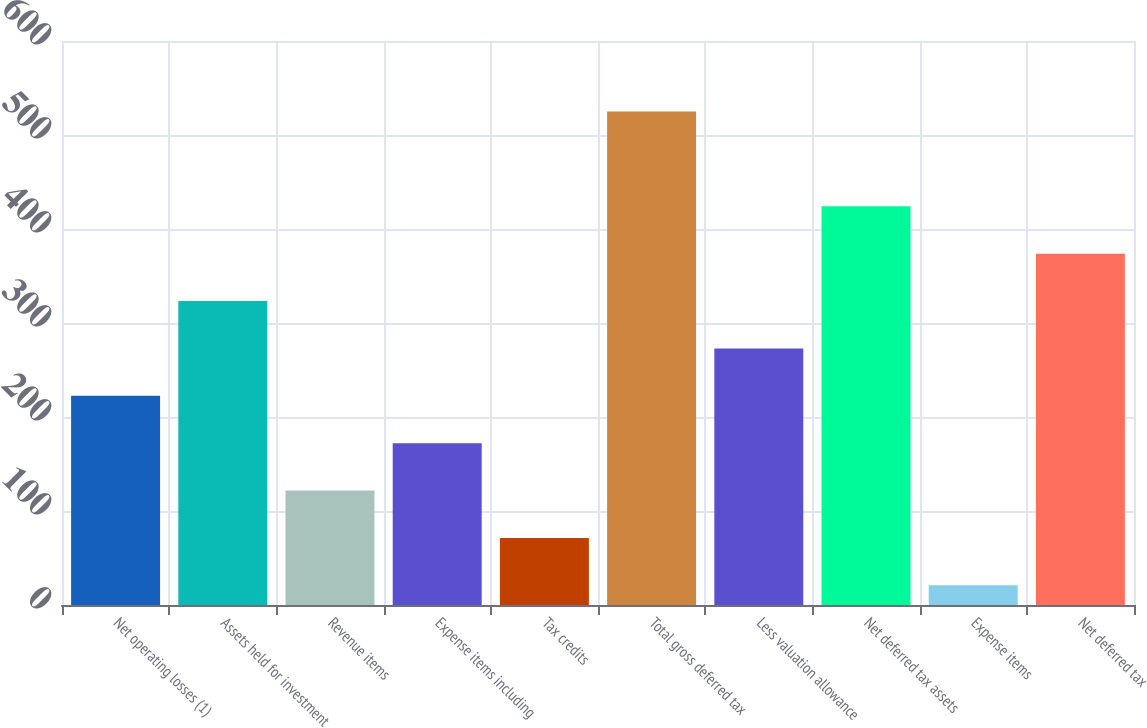Convert chart. <chart><loc_0><loc_0><loc_500><loc_500><bar_chart><fcel>Net operating losses (1)<fcel>Assets held for investment<fcel>Revenue items<fcel>Expense items including<fcel>Tax credits<fcel>Total gross deferred tax<fcel>Less valuation allowance<fcel>Net deferred tax assets<fcel>Expense items<fcel>Net deferred tax<nl><fcel>222.6<fcel>323.4<fcel>121.8<fcel>172.2<fcel>71.4<fcel>525<fcel>273<fcel>424.2<fcel>21<fcel>373.8<nl></chart> 